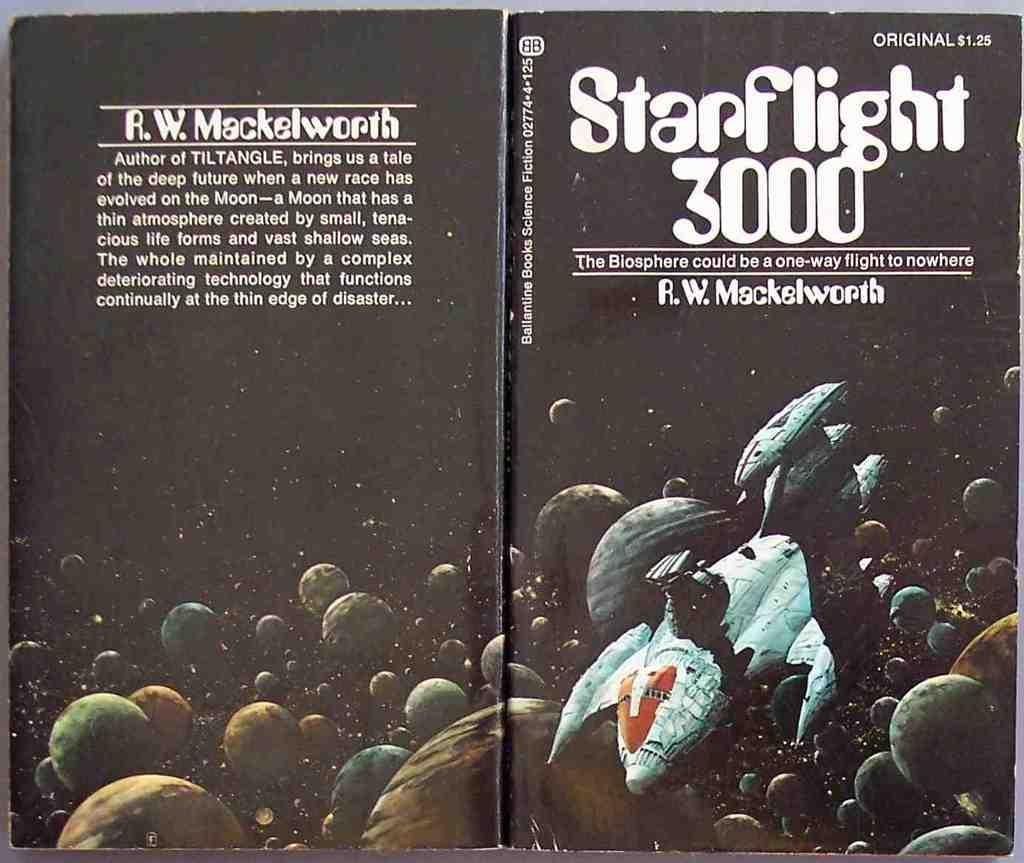<image>
Relay a brief, clear account of the picture shown. a book that is titled 'starflight 3000' on it 